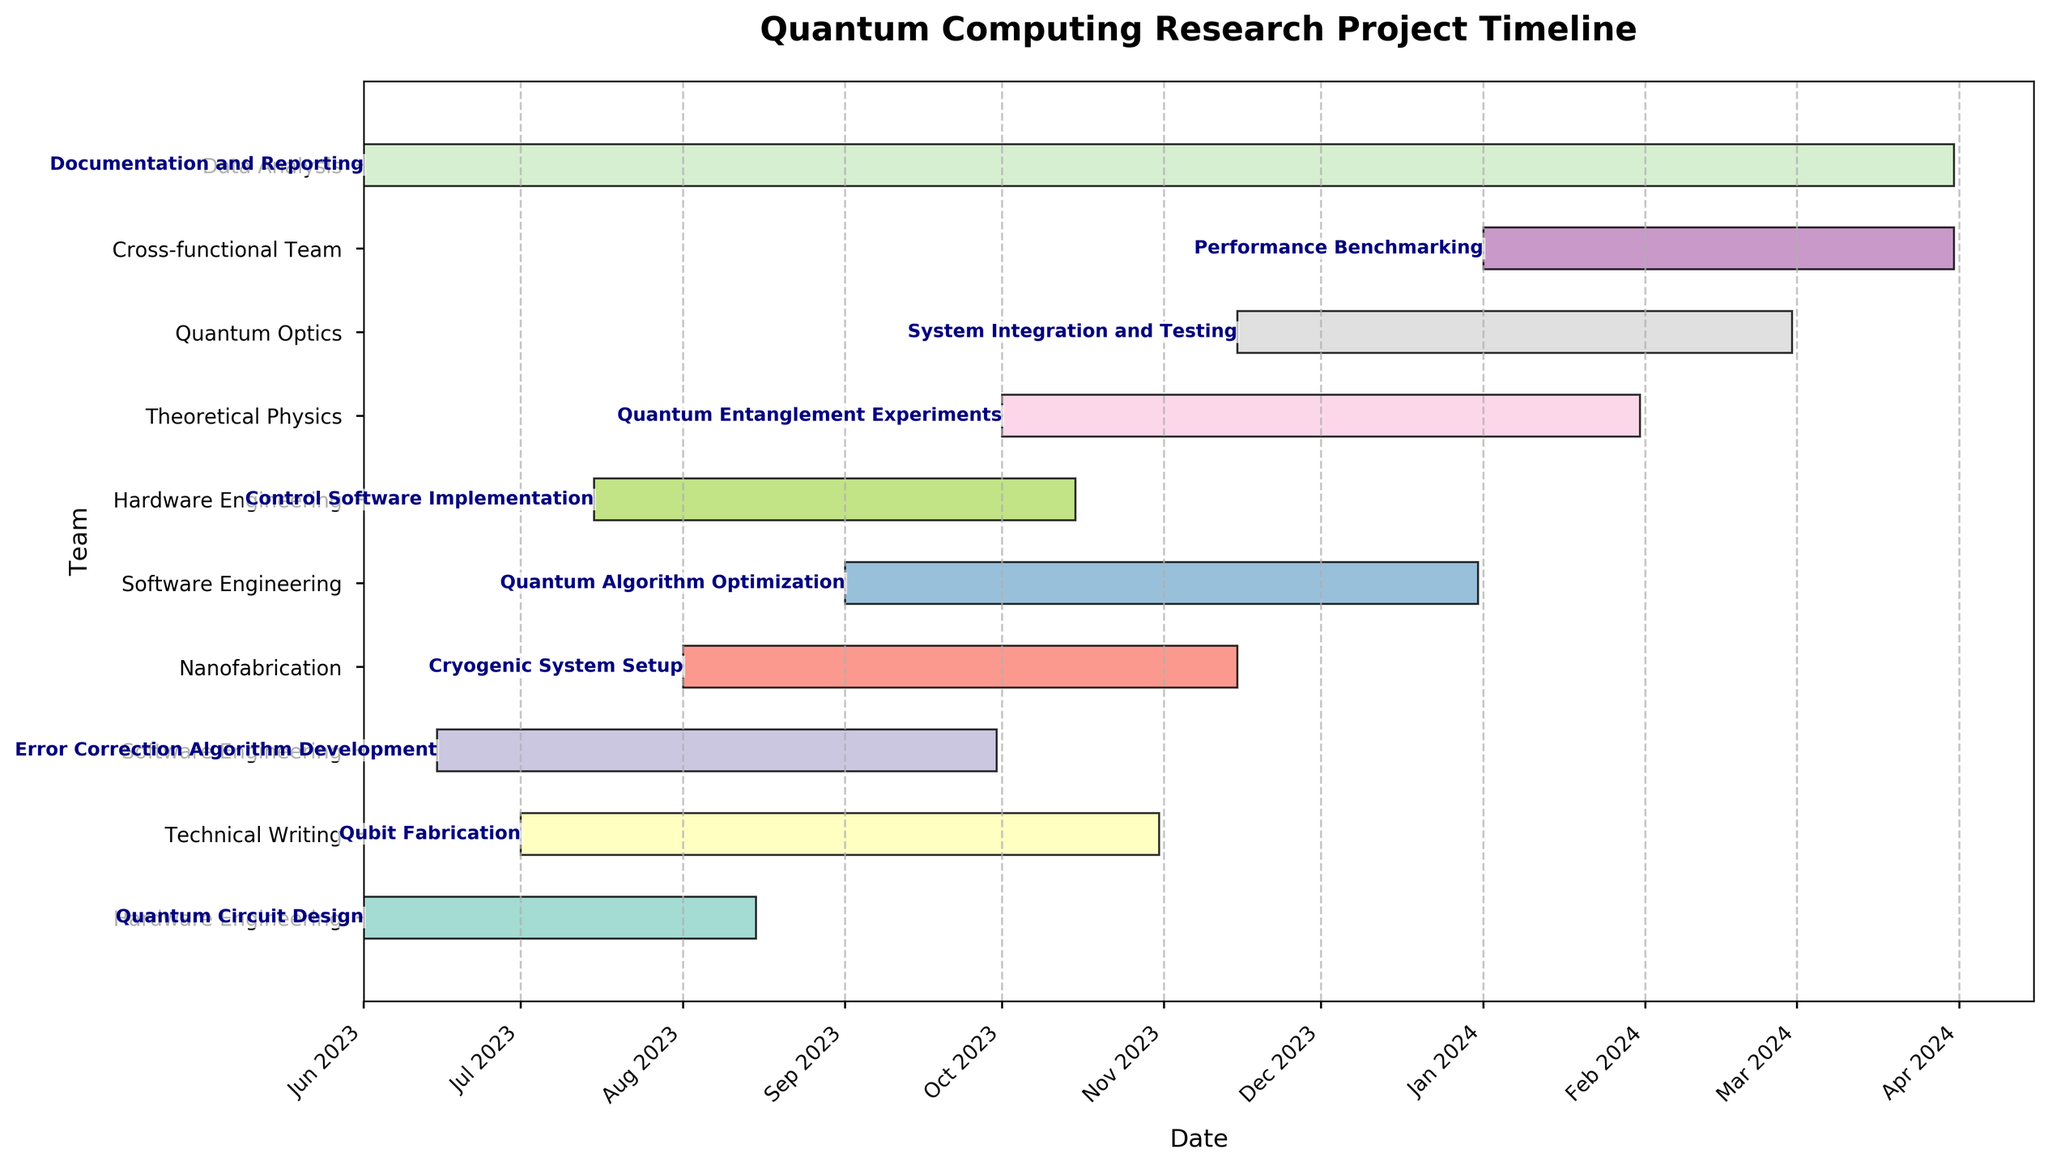What's the title of the Gantt chart? The title of a Gantt chart is usually found at the top of the chart and is prominently displayed. By looking at the top of the chart, you'll see "Quantum Computing Research Project Timeline" written in bold.
Answer: Quantum Computing Research Project Timeline Which team starts working first according to the Gantt chart? To determine which team starts first, look for the earliest "Start Date" on the Gantt chart. "Quantum Circuit Design" has the earliest start date of 2023-06-01, and it is handled by the Hardware Engineering team.
Answer: Hardware Engineering How long does the Qubit Fabrication task take? To find the duration of the Qubit Fabrication task, calculate the difference between its start and end dates. The task starts on 2023-07-01 and ends on 2023-10-31, which covers a span from July to October. Subtracting these dates, we get 123 days.
Answer: 123 days How many teams are involved in the project? To know the total number of teams, count the unique team names from the 'Team' column in the Gantt chart. There are six unique teams: Hardware Engineering, Nanofabrication, Software Engineering, Theoretical Physics, Quantum Optics, Cross-functional Team, Data Analysis, and Technical Writing.
Answer: 8 teams Which task ends last and when does it end? To find the task that ends last, look for the latest "End Date" on the Gantt chart. The "Documentation and Reporting" task ends on 2024-03-31, which is the latest end date.
Answer: Documentation and Reporting, 2024-03-31 Are there any overlapping tasks in the month of August 2023? If so, name them. To identify overlapping tasks in August 2023, look for tasks that have some shared time in their date ranges. Both "Quantum Circuit Design" (ends 2023-08-15) and "Qubit Fabrication" (starts 2023-07-01) overlap in August 2023, as do "Error Correction Algorithm Development" (starts 2023-06-15, ends 2023-09-30) and "Cryogenic System Setup" (starts 2023-08-01).
Answer: Quantum Circuit Design, Qubit Fabrication, Error Correction Algorithm Development, Cryogenic System Setup What is the time gap between the end of "Quantum Algorithm Optimization" and the start of "Quantum Entanglement Experiments"? To calculate the gap between these tasks, find the end date of "Quantum Algorithm Optimization" and the start date of "Quantum Entanglement Experiments". "Quantum Algorithm Optimization" ends on 2023-12-31, and "Quantum Entanglement Experiments" start on 2024-01-01. The gap is the difference between these two dates.
Answer: 1 day Which team has the most extended continuous task duration, and what is the duration? To find this, calculate the durations of tasks for each team and compare them. "Documentation and Reporting" by the Technical Writing team has the longest duration from 2023-06-01 to 2024-03-31, which is 305 days long.
Answer: Technical Writing, 305 days During which months is the Hardware Engineering team working on at least one task? Look at the tasks assigned to the Hardware Engineering team and identify their date ranges. "Quantum Circuit Design" (June 2023 - August 2023) and "Cryogenic System Setup" (August 2023 - November 2023) show that this team is active from June to November 2023.
Answer: June, July, August, September, October, November What is the average duration of tasks managed by the Software Engineering team? To find the average task duration for Software Engineering, calculate the durations of their tasks: "Error Correction Algorithm Development" (2023-06-15 to 2023-09-30, 107 days) and "Control Software Implementation" (2023-07-15 to 2023-10-15, 93 days). The average is (107 + 93) / 2 = 100 days.
Answer: 100 days 